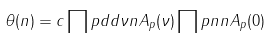Convert formula to latex. <formula><loc_0><loc_0><loc_500><loc_500>\theta ( n ) = c \prod p d d { \nu } { n } { A _ { p } ( \nu ) } \prod p n { n } { A _ { p } ( 0 ) }</formula> 